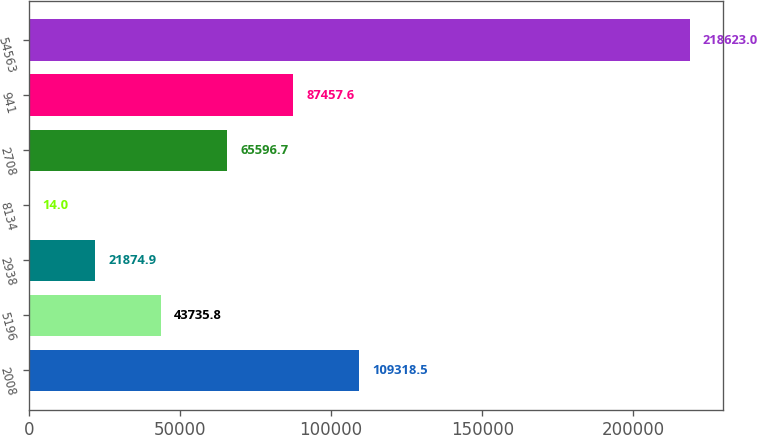<chart> <loc_0><loc_0><loc_500><loc_500><bar_chart><fcel>2008<fcel>5196<fcel>2938<fcel>8134<fcel>2708<fcel>941<fcel>54563<nl><fcel>109318<fcel>43735.8<fcel>21874.9<fcel>14<fcel>65596.7<fcel>87457.6<fcel>218623<nl></chart> 